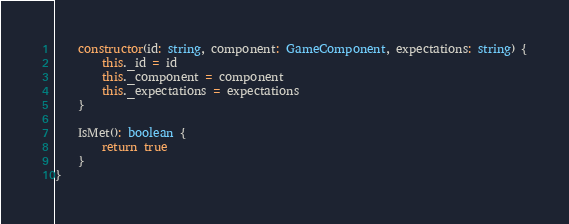Convert code to text. <code><loc_0><loc_0><loc_500><loc_500><_TypeScript_>    constructor(id: string, component: GameComponent, expectations: string) {
        this._id = id
        this._component = component
        this._expectations = expectations
    }

    IsMet(): boolean {
        return true
    }
}</code> 